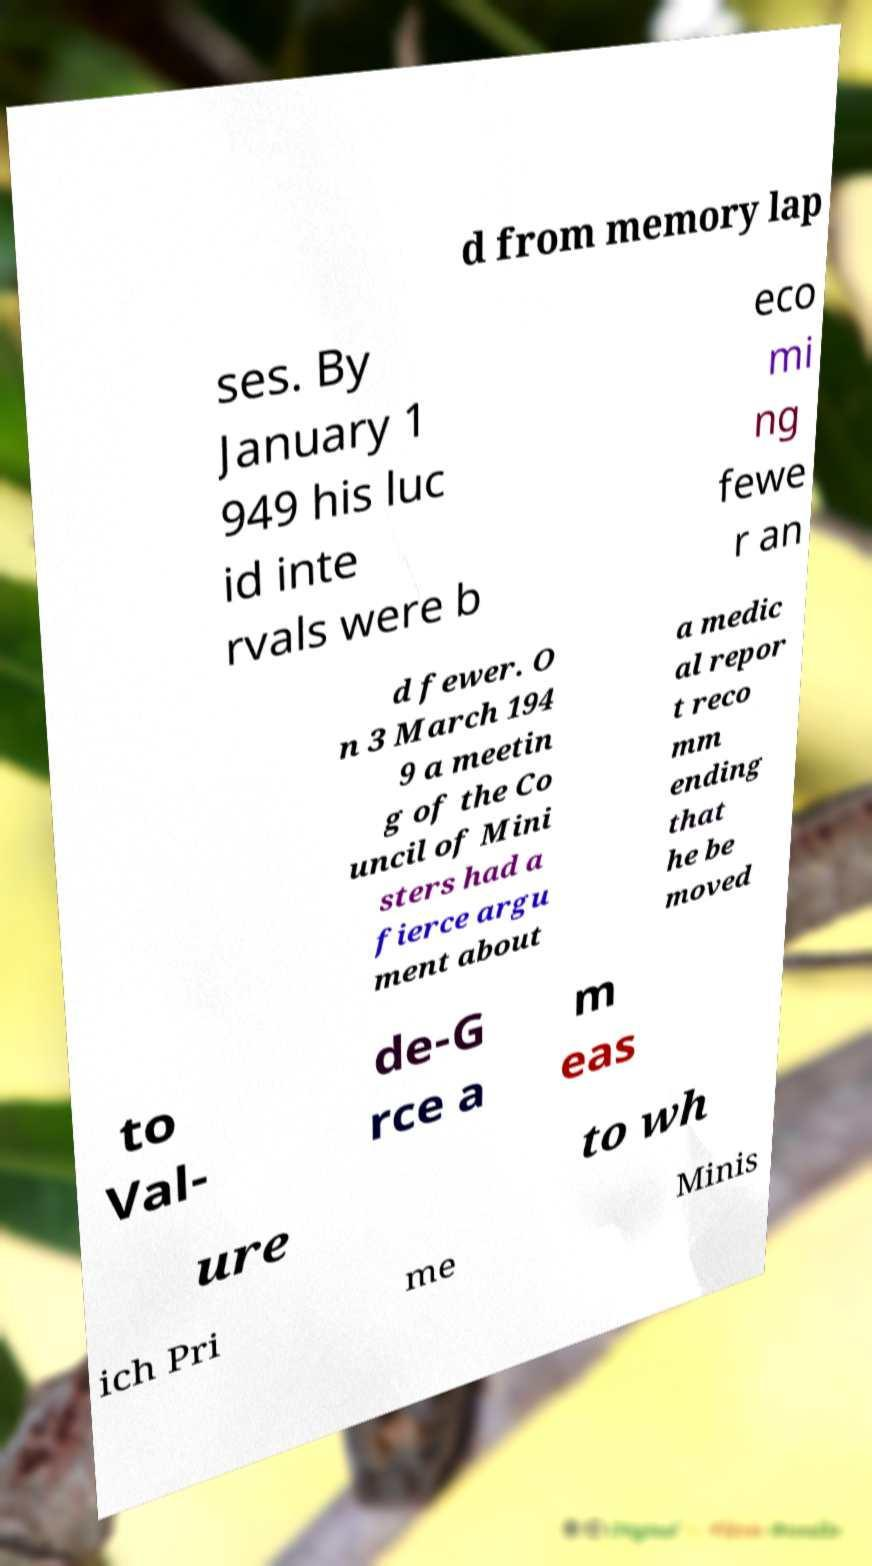There's text embedded in this image that I need extracted. Can you transcribe it verbatim? d from memory lap ses. By January 1 949 his luc id inte rvals were b eco mi ng fewe r an d fewer. O n 3 March 194 9 a meetin g of the Co uncil of Mini sters had a fierce argu ment about a medic al repor t reco mm ending that he be moved to Val- de-G rce a m eas ure to wh ich Pri me Minis 